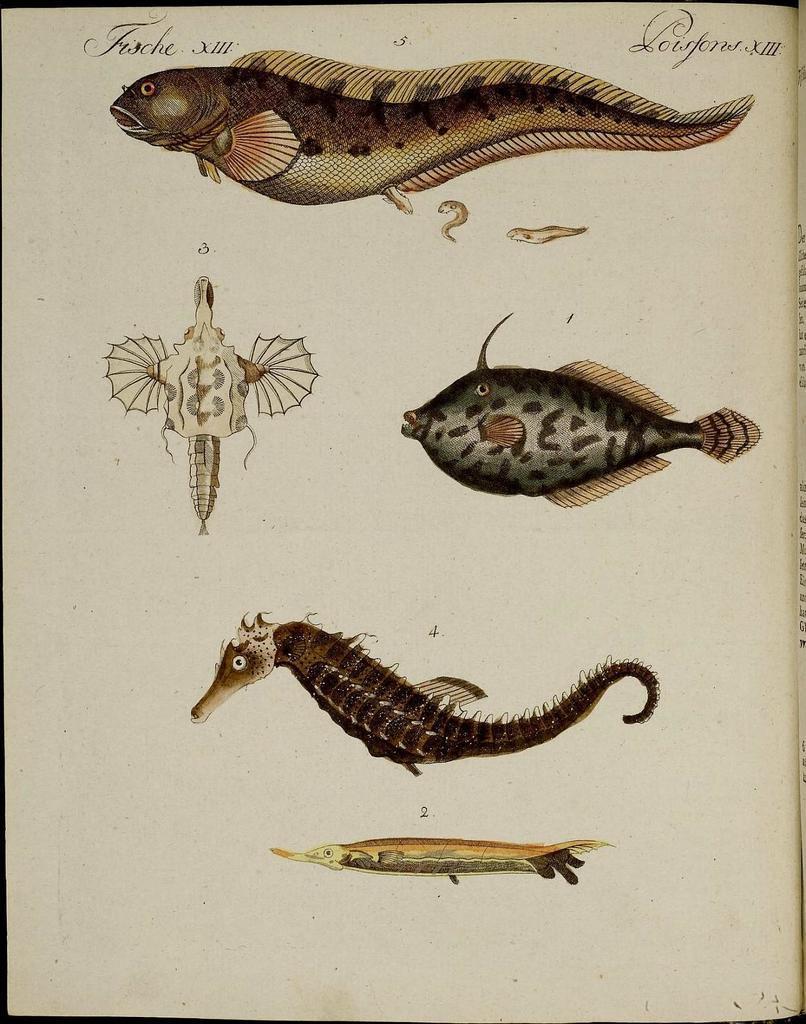Please provide a concise description of this image. This is a page and in this page we can see fishes and some text. 